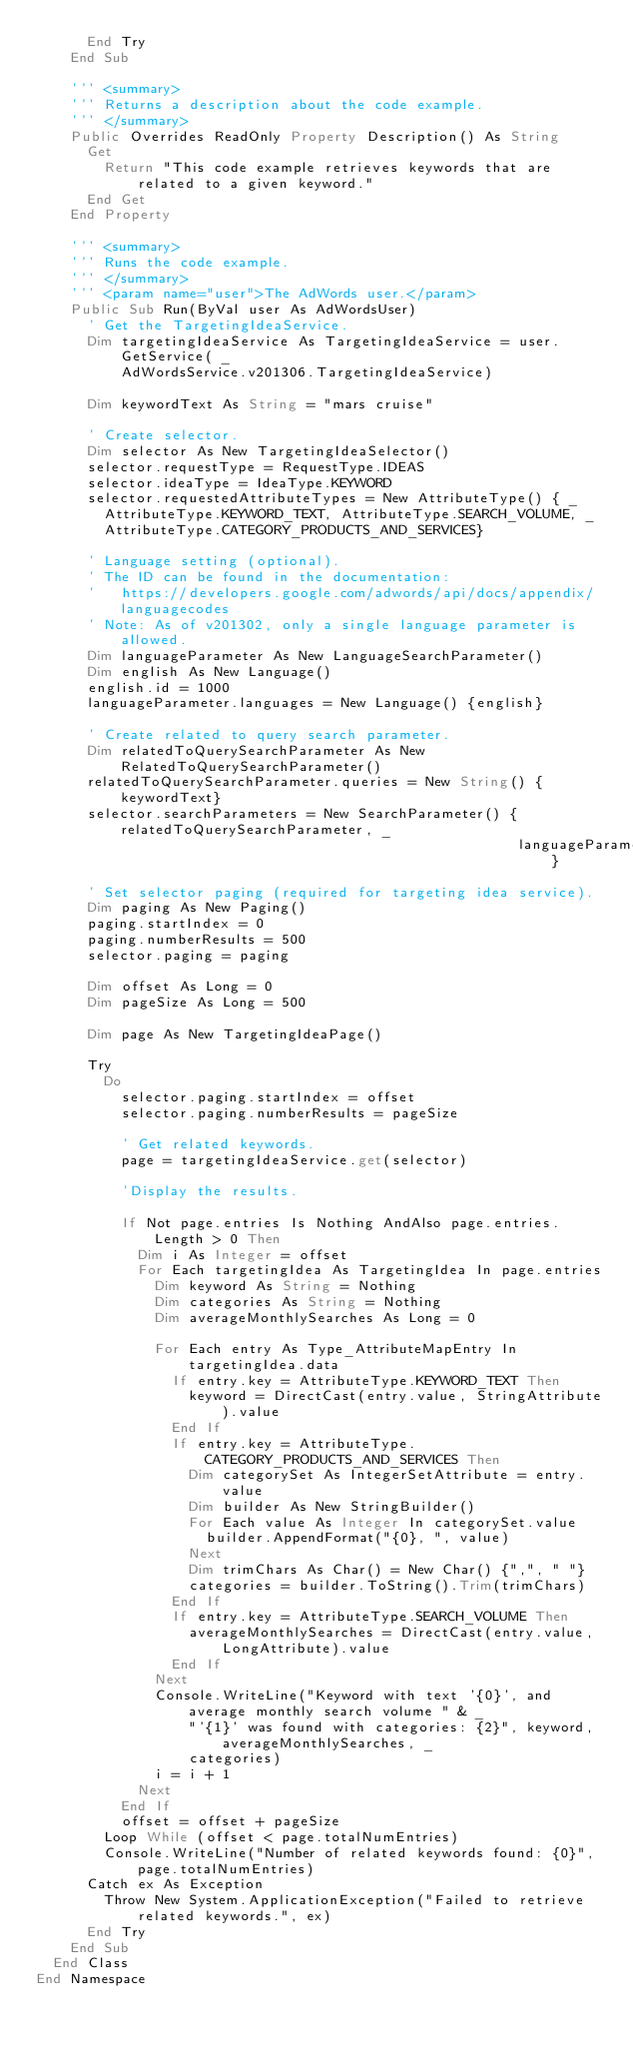<code> <loc_0><loc_0><loc_500><loc_500><_VisualBasic_>      End Try
    End Sub

    ''' <summary>
    ''' Returns a description about the code example.
    ''' </summary>
    Public Overrides ReadOnly Property Description() As String
      Get
        Return "This code example retrieves keywords that are related to a given keyword."
      End Get
    End Property

    ''' <summary>
    ''' Runs the code example.
    ''' </summary>
    ''' <param name="user">The AdWords user.</param>
    Public Sub Run(ByVal user As AdWordsUser)
      ' Get the TargetingIdeaService.
      Dim targetingIdeaService As TargetingIdeaService = user.GetService( _
          AdWordsService.v201306.TargetingIdeaService)

      Dim keywordText As String = "mars cruise"

      ' Create selector.
      Dim selector As New TargetingIdeaSelector()
      selector.requestType = RequestType.IDEAS
      selector.ideaType = IdeaType.KEYWORD
      selector.requestedAttributeTypes = New AttributeType() { _
        AttributeType.KEYWORD_TEXT, AttributeType.SEARCH_VOLUME, _
        AttributeType.CATEGORY_PRODUCTS_AND_SERVICES}

      ' Language setting (optional).
      ' The ID can be found in the documentation:
      '   https://developers.google.com/adwords/api/docs/appendix/languagecodes
      ' Note: As of v201302, only a single language parameter is allowed.
      Dim languageParameter As New LanguageSearchParameter()
      Dim english As New Language()
      english.id = 1000
      languageParameter.languages = New Language() {english}

      ' Create related to query search parameter.
      Dim relatedToQuerySearchParameter As New RelatedToQuerySearchParameter()
      relatedToQuerySearchParameter.queries = New String() {keywordText}
      selector.searchParameters = New SearchParameter() {relatedToQuerySearchParameter, _
                                                         languageParameter}

      ' Set selector paging (required for targeting idea service).
      Dim paging As New Paging()
      paging.startIndex = 0
      paging.numberResults = 500
      selector.paging = paging

      Dim offset As Long = 0
      Dim pageSize As Long = 500

      Dim page As New TargetingIdeaPage()

      Try
        Do
          selector.paging.startIndex = offset
          selector.paging.numberResults = pageSize

          ' Get related keywords.
          page = targetingIdeaService.get(selector)

          'Display the results.

          If Not page.entries Is Nothing AndAlso page.entries.Length > 0 Then
            Dim i As Integer = offset
            For Each targetingIdea As TargetingIdea In page.entries
              Dim keyword As String = Nothing
              Dim categories As String = Nothing
              Dim averageMonthlySearches As Long = 0

              For Each entry As Type_AttributeMapEntry In targetingIdea.data
                If entry.key = AttributeType.KEYWORD_TEXT Then
                  keyword = DirectCast(entry.value, StringAttribute).value
                End If
                If entry.key = AttributeType.CATEGORY_PRODUCTS_AND_SERVICES Then
                  Dim categorySet As IntegerSetAttribute = entry.value
                  Dim builder As New StringBuilder()
                  For Each value As Integer In categorySet.value
                    builder.AppendFormat("{0}, ", value)
                  Next
                  Dim trimChars As Char() = New Char() {",", " "}
                  categories = builder.ToString().Trim(trimChars)
                End If
                If entry.key = AttributeType.SEARCH_VOLUME Then
                  averageMonthlySearches = DirectCast(entry.value, LongAttribute).value
                End If
              Next
              Console.WriteLine("Keyword with text '{0}', and average monthly search volume " & _
                  "'{1}' was found with categories: {2}", keyword, averageMonthlySearches, _
                  categories)
              i = i + 1
            Next
          End If
          offset = offset + pageSize
        Loop While (offset < page.totalNumEntries)
        Console.WriteLine("Number of related keywords found: {0}", page.totalNumEntries)
      Catch ex As Exception
        Throw New System.ApplicationException("Failed to retrieve related keywords.", ex)
      End Try
    End Sub
  End Class
End Namespace
</code> 